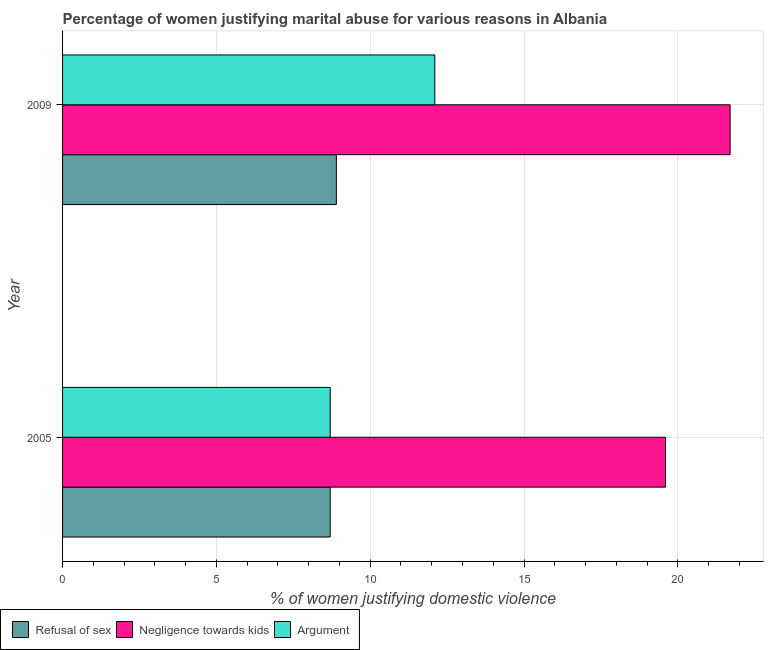Are the number of bars per tick equal to the number of legend labels?
Provide a succinct answer. Yes. How many bars are there on the 1st tick from the bottom?
Your answer should be very brief. 3. What is the label of the 2nd group of bars from the top?
Offer a terse response. 2005. Across all years, what is the maximum percentage of women justifying domestic violence due to arguments?
Your answer should be compact. 12.1. In which year was the percentage of women justifying domestic violence due to arguments maximum?
Keep it short and to the point. 2009. In which year was the percentage of women justifying domestic violence due to arguments minimum?
Offer a terse response. 2005. What is the total percentage of women justifying domestic violence due to refusal of sex in the graph?
Offer a terse response. 17.6. What is the difference between the percentage of women justifying domestic violence due to arguments in 2005 and that in 2009?
Provide a succinct answer. -3.4. What is the difference between the percentage of women justifying domestic violence due to negligence towards kids in 2009 and the percentage of women justifying domestic violence due to arguments in 2005?
Offer a very short reply. 13. What is the average percentage of women justifying domestic violence due to negligence towards kids per year?
Ensure brevity in your answer.  20.65. In the year 2005, what is the difference between the percentage of women justifying domestic violence due to negligence towards kids and percentage of women justifying domestic violence due to refusal of sex?
Give a very brief answer. 10.9. Is the percentage of women justifying domestic violence due to arguments in 2005 less than that in 2009?
Provide a short and direct response. Yes. Is the difference between the percentage of women justifying domestic violence due to refusal of sex in 2005 and 2009 greater than the difference between the percentage of women justifying domestic violence due to negligence towards kids in 2005 and 2009?
Keep it short and to the point. Yes. What does the 1st bar from the top in 2005 represents?
Your response must be concise. Argument. What does the 2nd bar from the bottom in 2009 represents?
Keep it short and to the point. Negligence towards kids. Is it the case that in every year, the sum of the percentage of women justifying domestic violence due to refusal of sex and percentage of women justifying domestic violence due to negligence towards kids is greater than the percentage of women justifying domestic violence due to arguments?
Provide a succinct answer. Yes. How many bars are there?
Provide a short and direct response. 6. Are all the bars in the graph horizontal?
Provide a succinct answer. Yes. What is the difference between two consecutive major ticks on the X-axis?
Your response must be concise. 5. Are the values on the major ticks of X-axis written in scientific E-notation?
Keep it short and to the point. No. Does the graph contain any zero values?
Keep it short and to the point. No. Does the graph contain grids?
Provide a succinct answer. Yes. How are the legend labels stacked?
Give a very brief answer. Horizontal. What is the title of the graph?
Provide a succinct answer. Percentage of women justifying marital abuse for various reasons in Albania. What is the label or title of the X-axis?
Your response must be concise. % of women justifying domestic violence. What is the % of women justifying domestic violence of Refusal of sex in 2005?
Provide a succinct answer. 8.7. What is the % of women justifying domestic violence in Negligence towards kids in 2005?
Make the answer very short. 19.6. What is the % of women justifying domestic violence in Negligence towards kids in 2009?
Your answer should be very brief. 21.7. What is the % of women justifying domestic violence in Argument in 2009?
Provide a succinct answer. 12.1. Across all years, what is the maximum % of women justifying domestic violence of Negligence towards kids?
Give a very brief answer. 21.7. Across all years, what is the minimum % of women justifying domestic violence of Refusal of sex?
Keep it short and to the point. 8.7. Across all years, what is the minimum % of women justifying domestic violence of Negligence towards kids?
Keep it short and to the point. 19.6. Across all years, what is the minimum % of women justifying domestic violence in Argument?
Provide a succinct answer. 8.7. What is the total % of women justifying domestic violence in Refusal of sex in the graph?
Your response must be concise. 17.6. What is the total % of women justifying domestic violence in Negligence towards kids in the graph?
Offer a terse response. 41.3. What is the total % of women justifying domestic violence of Argument in the graph?
Your answer should be compact. 20.8. What is the difference between the % of women justifying domestic violence of Negligence towards kids in 2005 and that in 2009?
Offer a very short reply. -2.1. What is the difference between the % of women justifying domestic violence in Argument in 2005 and that in 2009?
Provide a short and direct response. -3.4. What is the difference between the % of women justifying domestic violence of Refusal of sex in 2005 and the % of women justifying domestic violence of Negligence towards kids in 2009?
Provide a succinct answer. -13. What is the difference between the % of women justifying domestic violence in Refusal of sex in 2005 and the % of women justifying domestic violence in Argument in 2009?
Your response must be concise. -3.4. What is the difference between the % of women justifying domestic violence of Negligence towards kids in 2005 and the % of women justifying domestic violence of Argument in 2009?
Ensure brevity in your answer.  7.5. What is the average % of women justifying domestic violence of Refusal of sex per year?
Your response must be concise. 8.8. What is the average % of women justifying domestic violence of Negligence towards kids per year?
Provide a succinct answer. 20.65. What is the average % of women justifying domestic violence of Argument per year?
Provide a succinct answer. 10.4. In the year 2009, what is the difference between the % of women justifying domestic violence of Refusal of sex and % of women justifying domestic violence of Argument?
Offer a very short reply. -3.2. What is the ratio of the % of women justifying domestic violence of Refusal of sex in 2005 to that in 2009?
Offer a terse response. 0.98. What is the ratio of the % of women justifying domestic violence in Negligence towards kids in 2005 to that in 2009?
Keep it short and to the point. 0.9. What is the ratio of the % of women justifying domestic violence of Argument in 2005 to that in 2009?
Make the answer very short. 0.72. What is the difference between the highest and the second highest % of women justifying domestic violence in Refusal of sex?
Offer a terse response. 0.2. What is the difference between the highest and the lowest % of women justifying domestic violence of Negligence towards kids?
Offer a terse response. 2.1. 